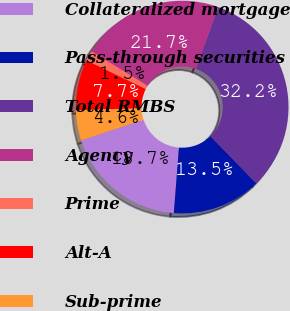Convert chart to OTSL. <chart><loc_0><loc_0><loc_500><loc_500><pie_chart><fcel>Collateralized mortgage<fcel>Pass-through securities<fcel>Total RMBS<fcel>Agency<fcel>Prime<fcel>Alt-A<fcel>Sub-prime<nl><fcel>18.68%<fcel>13.53%<fcel>32.21%<fcel>21.75%<fcel>1.55%<fcel>7.68%<fcel>4.61%<nl></chart> 